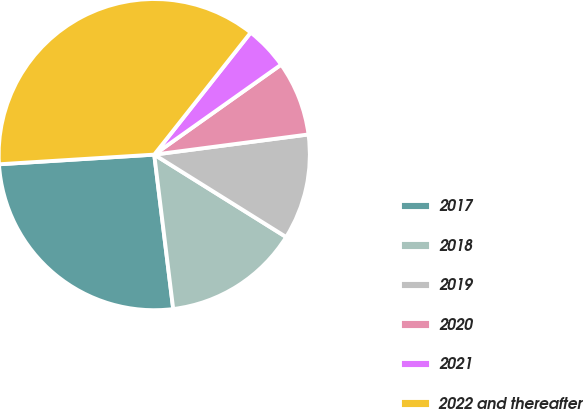<chart> <loc_0><loc_0><loc_500><loc_500><pie_chart><fcel>2017<fcel>2018<fcel>2019<fcel>2020<fcel>2021<fcel>2022 and thereafter<nl><fcel>25.96%<fcel>14.17%<fcel>10.96%<fcel>7.75%<fcel>4.54%<fcel>36.64%<nl></chart> 